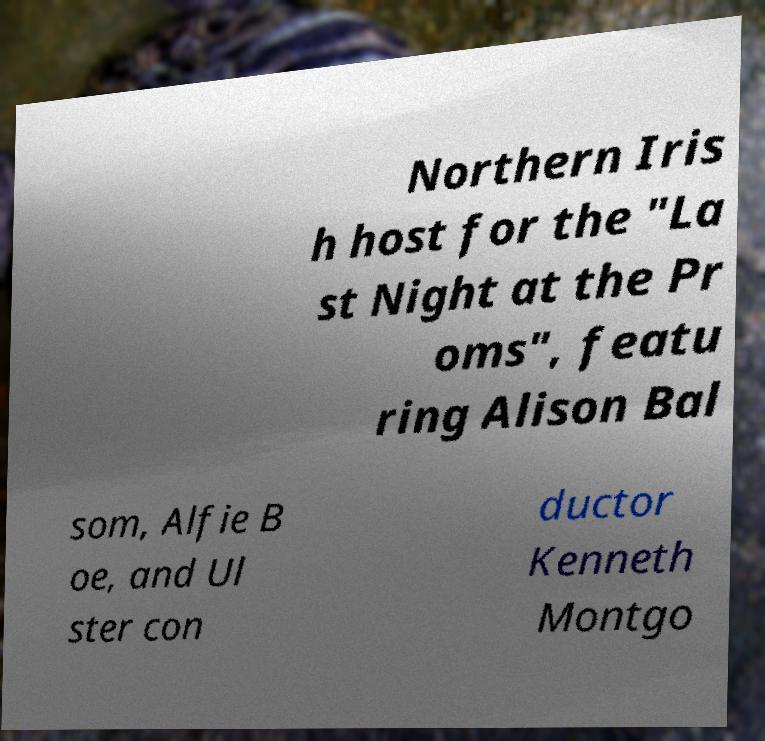Could you extract and type out the text from this image? Northern Iris h host for the "La st Night at the Pr oms", featu ring Alison Bal som, Alfie B oe, and Ul ster con ductor Kenneth Montgo 